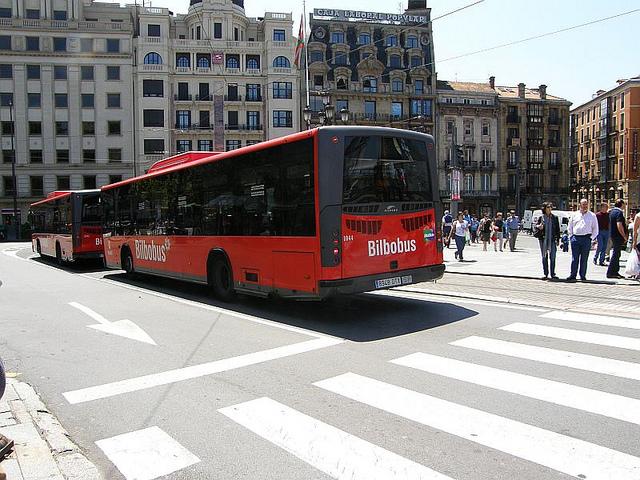Is this a train depot?
Concise answer only. No. What it that red vehicle?
Quick response, please. Bus. Is this a bus stop?
Short answer required. No. Is this in America?
Be succinct. No. 